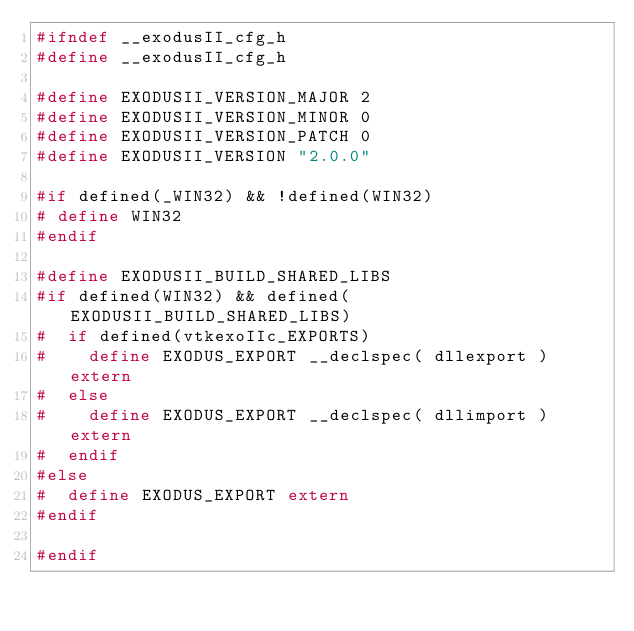<code> <loc_0><loc_0><loc_500><loc_500><_C_>#ifndef __exodusII_cfg_h
#define __exodusII_cfg_h

#define EXODUSII_VERSION_MAJOR 2
#define EXODUSII_VERSION_MINOR 0
#define EXODUSII_VERSION_PATCH 0
#define EXODUSII_VERSION "2.0.0"

#if defined(_WIN32) && !defined(WIN32)
# define WIN32
#endif

#define EXODUSII_BUILD_SHARED_LIBS
#if defined(WIN32) && defined(EXODUSII_BUILD_SHARED_LIBS)
#  if defined(vtkexoIIc_EXPORTS)
#    define EXODUS_EXPORT __declspec( dllexport ) extern
#  else
#    define EXODUS_EXPORT __declspec( dllimport ) extern
#  endif
#else
#  define EXODUS_EXPORT extern
#endif

#endif

</code> 